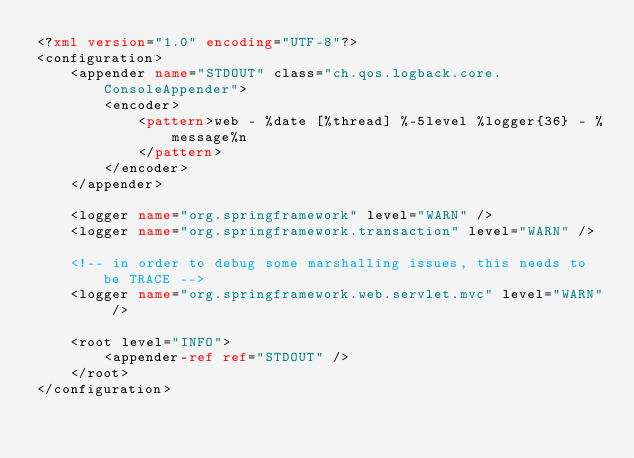<code> <loc_0><loc_0><loc_500><loc_500><_XML_><?xml version="1.0" encoding="UTF-8"?>
<configuration>
    <appender name="STDOUT" class="ch.qos.logback.core.ConsoleAppender">
        <encoder>
            <pattern>web - %date [%thread] %-5level %logger{36} - %message%n
            </pattern>
        </encoder>
    </appender>

    <logger name="org.springframework" level="WARN" />
    <logger name="org.springframework.transaction" level="WARN" />

    <!-- in order to debug some marshalling issues, this needs to be TRACE -->
    <logger name="org.springframework.web.servlet.mvc" level="WARN" />

    <root level="INFO">
        <appender-ref ref="STDOUT" />
    </root>
</configuration></code> 